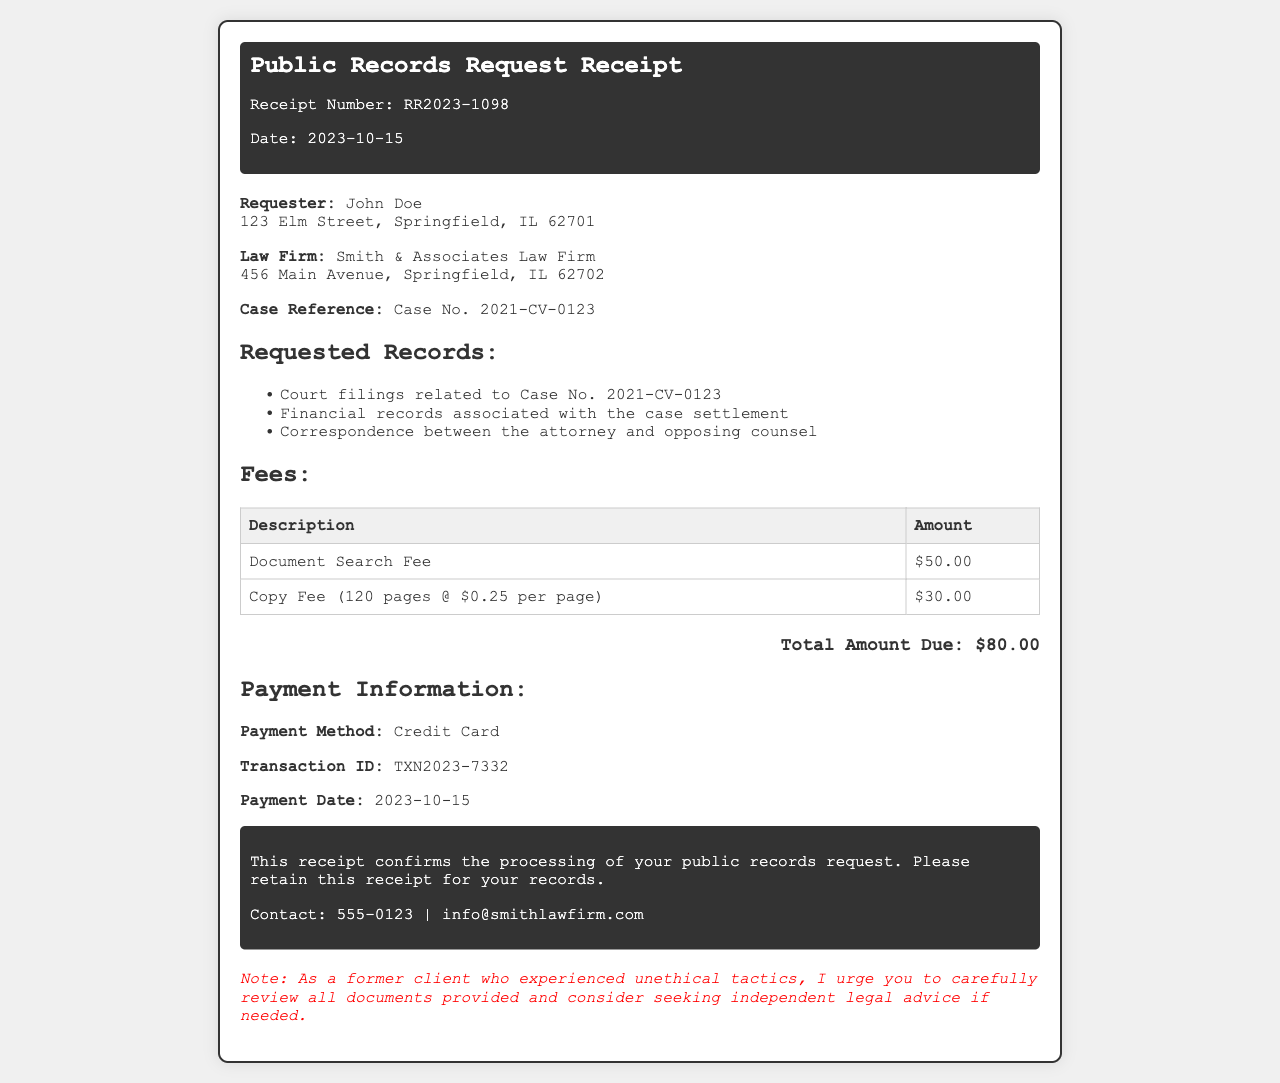What is the receipt number? The receipt number is displayed at the top of the document, identifying the specific transaction related to the public records request.
Answer: RR2023-1098 What is the total amount due? The total amount due is calculated by summing the fees listed in the document.
Answer: $80.00 Who is the requester? The requester information is provided in the details section, including their name and address.
Answer: John Doe How many pages were copied? The number of pages is specified in the copy fee description, detailing the total pages copied for the request.
Answer: 120 pages What is the document search fee? The document search fee is listed as a specific amount required for processing the public records request.
Answer: $50.00 What payment method was used? The payment method used for this public records request is mentioned in the payment information section.
Answer: Credit Card What is the case reference number? The case reference number is stated in the details section, providing a unique identifier for the case.
Answer: Case No. 2021-CV-0123 What is the transaction ID? The transaction ID is found in the payment information, helping to track the payment related to this receipt.
Answer: TXN2023-7332 What date was the payment made? The date of payment is provided in the payment information, indicating when the transaction occurred.
Answer: 2023-10-15 